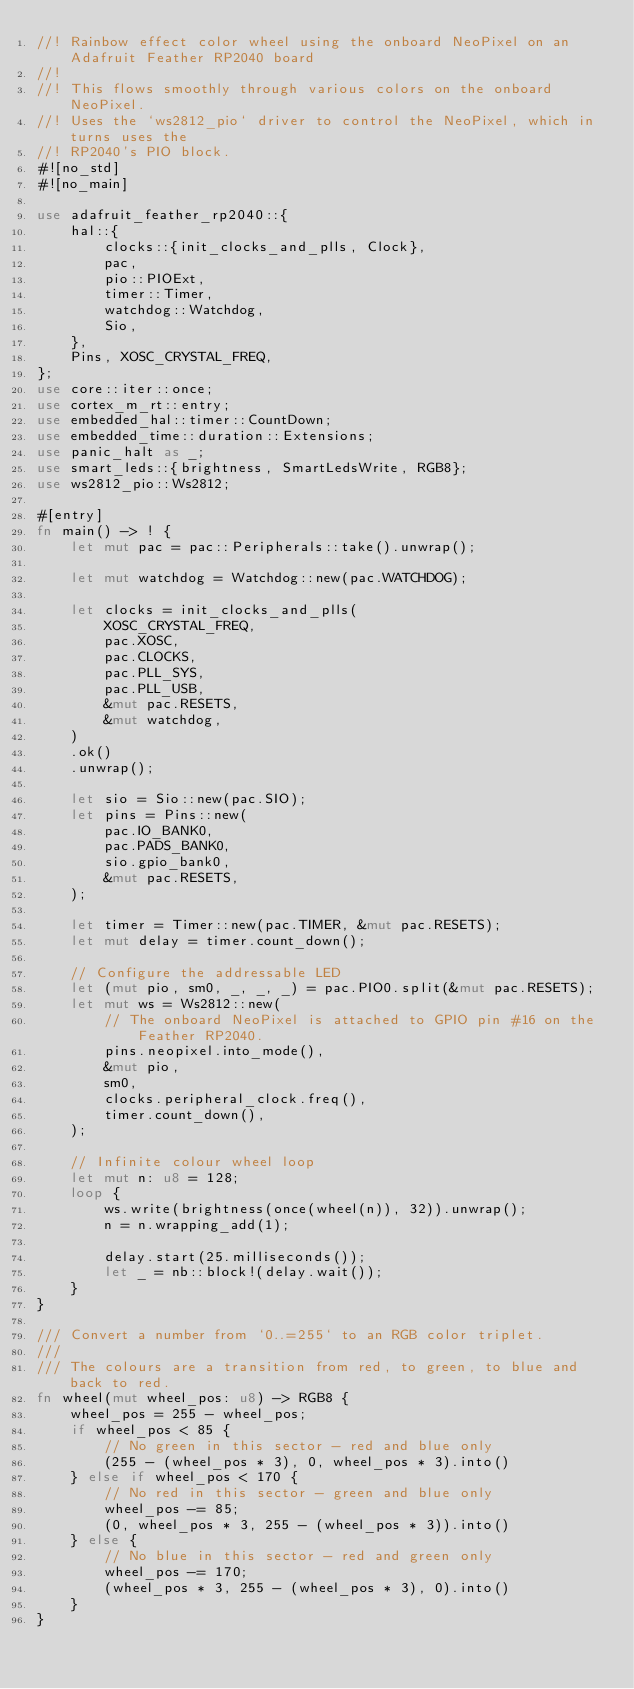<code> <loc_0><loc_0><loc_500><loc_500><_Rust_>//! Rainbow effect color wheel using the onboard NeoPixel on an Adafruit Feather RP2040 board
//!
//! This flows smoothly through various colors on the onboard NeoPixel.
//! Uses the `ws2812_pio` driver to control the NeoPixel, which in turns uses the
//! RP2040's PIO block.
#![no_std]
#![no_main]

use adafruit_feather_rp2040::{
    hal::{
        clocks::{init_clocks_and_plls, Clock},
        pac,
        pio::PIOExt,
        timer::Timer,
        watchdog::Watchdog,
        Sio,
    },
    Pins, XOSC_CRYSTAL_FREQ,
};
use core::iter::once;
use cortex_m_rt::entry;
use embedded_hal::timer::CountDown;
use embedded_time::duration::Extensions;
use panic_halt as _;
use smart_leds::{brightness, SmartLedsWrite, RGB8};
use ws2812_pio::Ws2812;

#[entry]
fn main() -> ! {
    let mut pac = pac::Peripherals::take().unwrap();

    let mut watchdog = Watchdog::new(pac.WATCHDOG);

    let clocks = init_clocks_and_plls(
        XOSC_CRYSTAL_FREQ,
        pac.XOSC,
        pac.CLOCKS,
        pac.PLL_SYS,
        pac.PLL_USB,
        &mut pac.RESETS,
        &mut watchdog,
    )
    .ok()
    .unwrap();

    let sio = Sio::new(pac.SIO);
    let pins = Pins::new(
        pac.IO_BANK0,
        pac.PADS_BANK0,
        sio.gpio_bank0,
        &mut pac.RESETS,
    );

    let timer = Timer::new(pac.TIMER, &mut pac.RESETS);
    let mut delay = timer.count_down();

    // Configure the addressable LED
    let (mut pio, sm0, _, _, _) = pac.PIO0.split(&mut pac.RESETS);
    let mut ws = Ws2812::new(
        // The onboard NeoPixel is attached to GPIO pin #16 on the Feather RP2040.
        pins.neopixel.into_mode(),
        &mut pio,
        sm0,
        clocks.peripheral_clock.freq(),
        timer.count_down(),
    );

    // Infinite colour wheel loop
    let mut n: u8 = 128;
    loop {
        ws.write(brightness(once(wheel(n)), 32)).unwrap();
        n = n.wrapping_add(1);

        delay.start(25.milliseconds());
        let _ = nb::block!(delay.wait());
    }
}

/// Convert a number from `0..=255` to an RGB color triplet.
///
/// The colours are a transition from red, to green, to blue and back to red.
fn wheel(mut wheel_pos: u8) -> RGB8 {
    wheel_pos = 255 - wheel_pos;
    if wheel_pos < 85 {
        // No green in this sector - red and blue only
        (255 - (wheel_pos * 3), 0, wheel_pos * 3).into()
    } else if wheel_pos < 170 {
        // No red in this sector - green and blue only
        wheel_pos -= 85;
        (0, wheel_pos * 3, 255 - (wheel_pos * 3)).into()
    } else {
        // No blue in this sector - red and green only
        wheel_pos -= 170;
        (wheel_pos * 3, 255 - (wheel_pos * 3), 0).into()
    }
}
</code> 